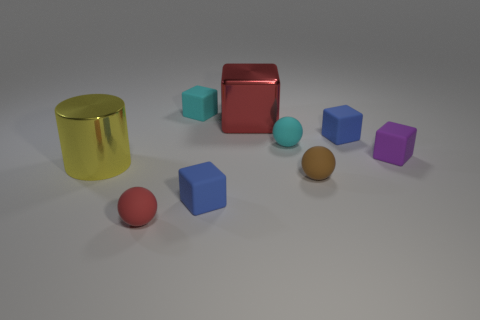Subtract all cyan blocks. How many blocks are left? 4 Subtract 2 blocks. How many blocks are left? 3 Subtract all cyan rubber cubes. How many cubes are left? 4 Subtract all brown cylinders. Subtract all blue blocks. How many cylinders are left? 1 Add 1 purple shiny balls. How many objects exist? 10 Subtract all cylinders. How many objects are left? 8 Add 2 red blocks. How many red blocks are left? 3 Add 4 big green metal cubes. How many big green metal cubes exist? 4 Subtract 1 blue cubes. How many objects are left? 8 Subtract all tiny yellow shiny spheres. Subtract all large shiny cylinders. How many objects are left? 8 